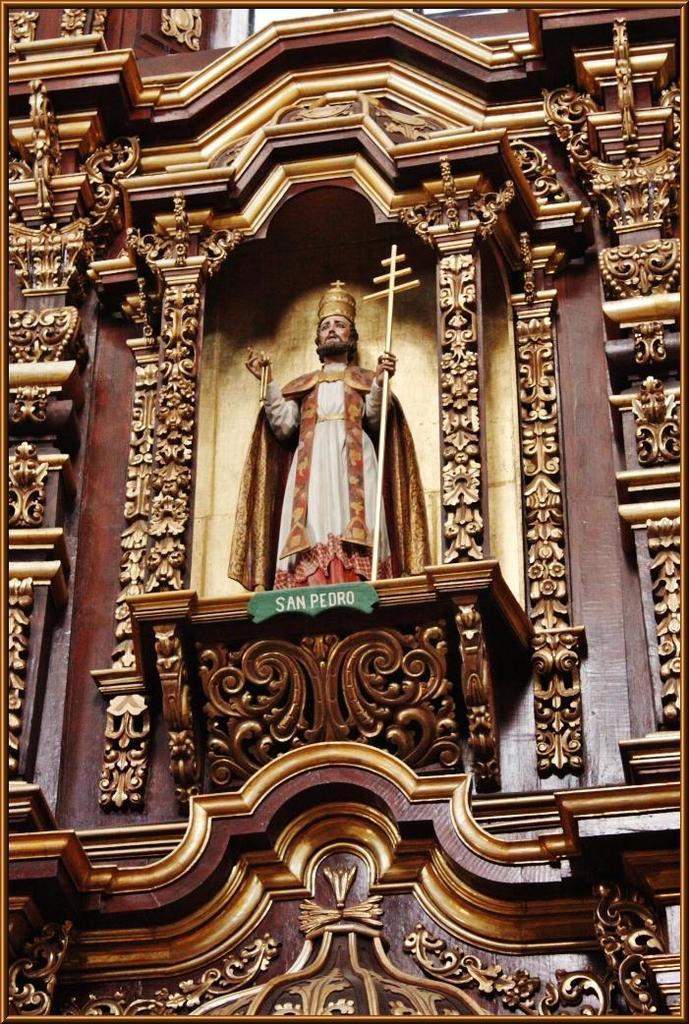How would you summarize this image in a sentence or two? In this picture there is a statue and there is a text on the wall and there is a floral architecture on the wall. 